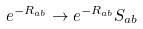Convert formula to latex. <formula><loc_0><loc_0><loc_500><loc_500>e ^ { - R _ { a b } } \to e ^ { - R _ { a b } } S _ { a b }</formula> 